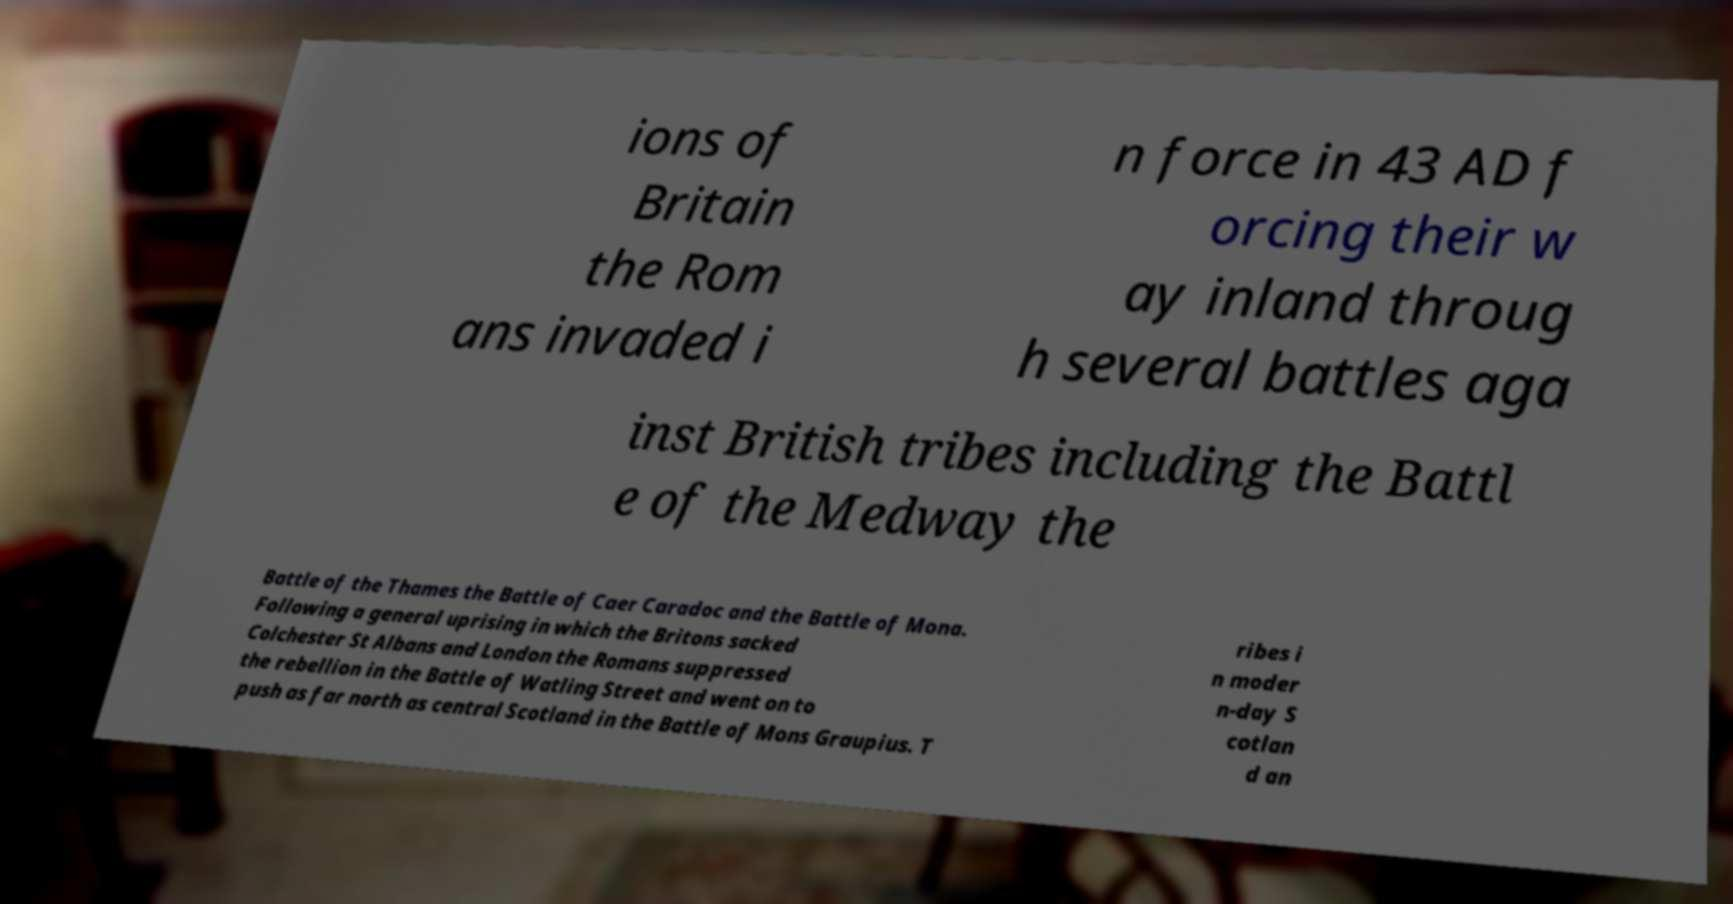I need the written content from this picture converted into text. Can you do that? ions of Britain the Rom ans invaded i n force in 43 AD f orcing their w ay inland throug h several battles aga inst British tribes including the Battl e of the Medway the Battle of the Thames the Battle of Caer Caradoc and the Battle of Mona. Following a general uprising in which the Britons sacked Colchester St Albans and London the Romans suppressed the rebellion in the Battle of Watling Street and went on to push as far north as central Scotland in the Battle of Mons Graupius. T ribes i n moder n-day S cotlan d an 